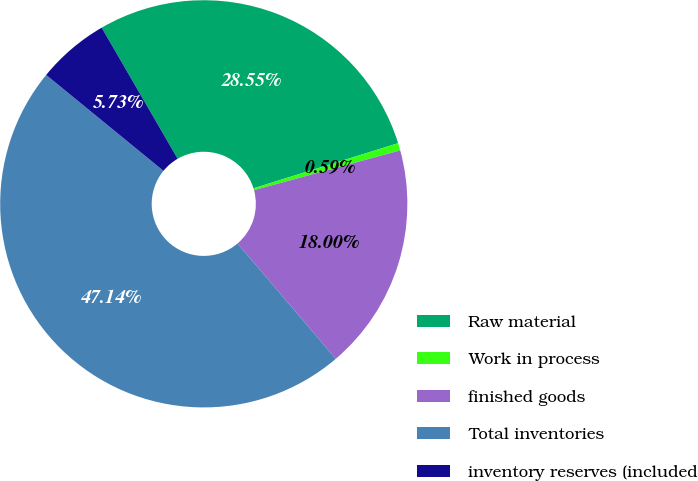<chart> <loc_0><loc_0><loc_500><loc_500><pie_chart><fcel>Raw material<fcel>Work in process<fcel>finished goods<fcel>Total inventories<fcel>inventory reserves (included<nl><fcel>28.55%<fcel>0.59%<fcel>18.0%<fcel>47.14%<fcel>5.73%<nl></chart> 